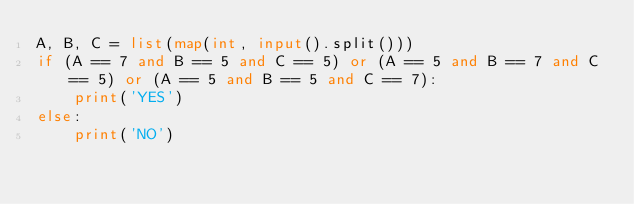<code> <loc_0><loc_0><loc_500><loc_500><_Python_>A, B, C = list(map(int, input().split()))
if (A == 7 and B == 5 and C == 5) or (A == 5 and B == 7 and C == 5) or (A == 5 and B == 5 and C == 7):
    print('YES')
else:
    print('NO')</code> 